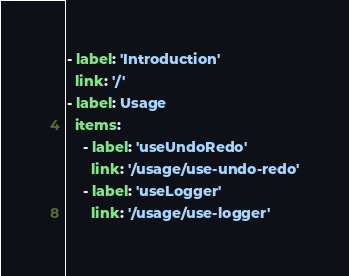Convert code to text. <code><loc_0><loc_0><loc_500><loc_500><_YAML_>- label: 'Introduction'
  link: '/'
- label: Usage
  items:
    - label: 'useUndoRedo'
      link: '/usage/use-undo-redo'
    - label: 'useLogger'
      link: '/usage/use-logger'</code> 